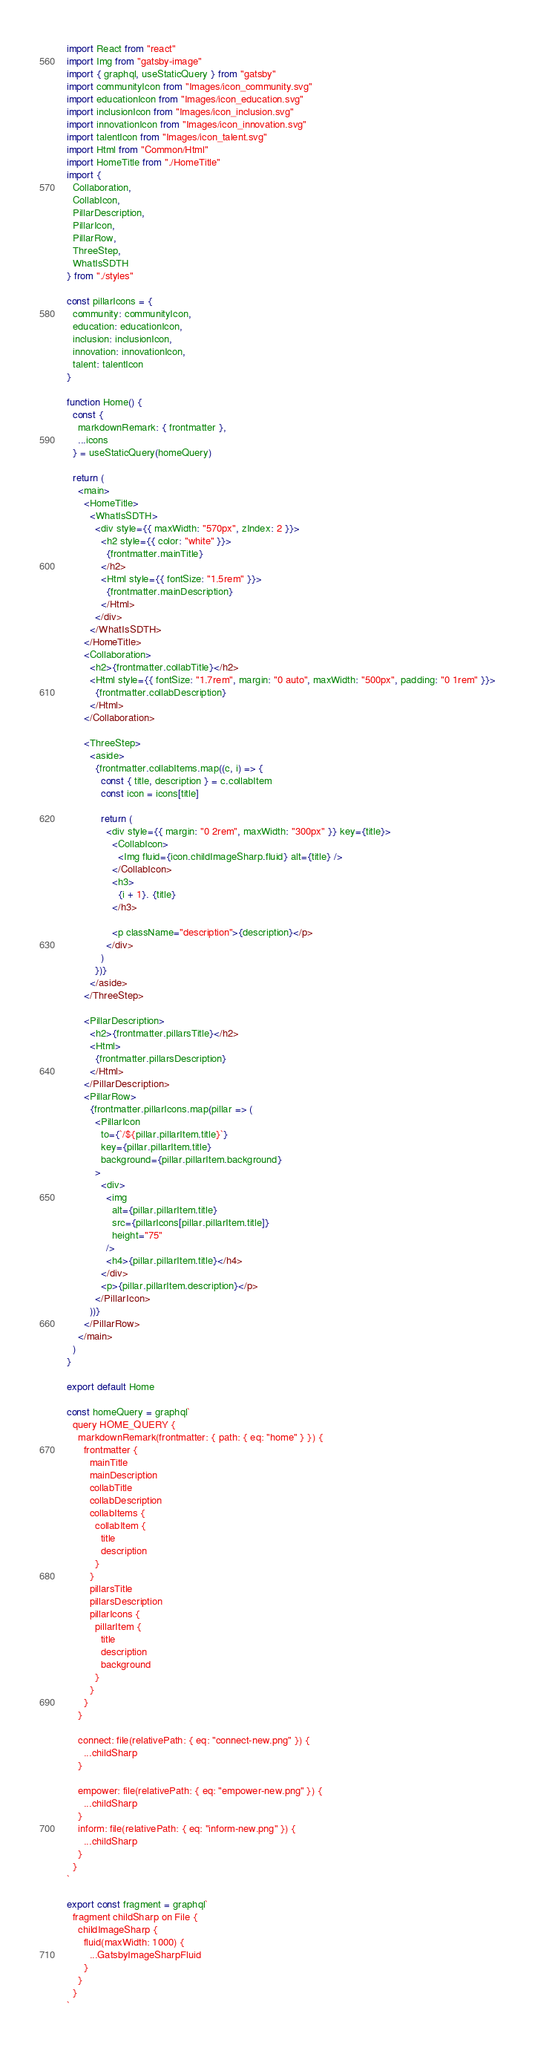<code> <loc_0><loc_0><loc_500><loc_500><_JavaScript_>import React from "react"
import Img from "gatsby-image"
import { graphql, useStaticQuery } from "gatsby"
import communityIcon from "Images/icon_community.svg"
import educationIcon from "Images/icon_education.svg"
import inclusionIcon from "Images/icon_inclusion.svg"
import innovationIcon from "Images/icon_innovation.svg"
import talentIcon from "Images/icon_talent.svg"
import Html from "Common/Html"
import HomeTitle from "./HomeTitle"
import {
  Collaboration,
  CollabIcon,
  PillarDescription,
  PillarIcon,
  PillarRow,
  ThreeStep,
  WhatIsSDTH
} from "./styles"

const pillarIcons = {
  community: communityIcon,
  education: educationIcon,
  inclusion: inclusionIcon,
  innovation: innovationIcon,
  talent: talentIcon
}

function Home() {
  const {
    markdownRemark: { frontmatter },
    ...icons
  } = useStaticQuery(homeQuery)

  return (
    <main>
      <HomeTitle>
        <WhatIsSDTH>
          <div style={{ maxWidth: "570px", zIndex: 2 }}>
            <h2 style={{ color: "white" }}>
              {frontmatter.mainTitle}
            </h2>
            <Html style={{ fontSize: "1.5rem" }}>
              {frontmatter.mainDescription}
            </Html>
          </div>
        </WhatIsSDTH>
      </HomeTitle>
      <Collaboration>
        <h2>{frontmatter.collabTitle}</h2>
        <Html style={{ fontSize: "1.7rem", margin: "0 auto", maxWidth: "500px", padding: "0 1rem" }}>
          {frontmatter.collabDescription}
        </Html>
      </Collaboration>

      <ThreeStep>
        <aside>
          {frontmatter.collabItems.map((c, i) => {
            const { title, description } = c.collabItem
            const icon = icons[title]

            return (
              <div style={{ margin: "0 2rem", maxWidth: "300px" }} key={title}>
                <CollabIcon>
                  <Img fluid={icon.childImageSharp.fluid} alt={title} />
                </CollabIcon>
                <h3>
                  {i + 1}. {title}
                </h3>

                <p className="description">{description}</p>
              </div>
            )
          })}
        </aside>
      </ThreeStep>

      <PillarDescription>
        <h2>{frontmatter.pillarsTitle}</h2>
        <Html>
          {frontmatter.pillarsDescription}
        </Html>
      </PillarDescription>
      <PillarRow>
        {frontmatter.pillarIcons.map(pillar => (
          <PillarIcon
            to={`/${pillar.pillarItem.title}`}
            key={pillar.pillarItem.title}
            background={pillar.pillarItem.background}
          >
            <div>
              <img
                alt={pillar.pillarItem.title}
                src={pillarIcons[pillar.pillarItem.title]}
                height="75"
              />
              <h4>{pillar.pillarItem.title}</h4>
            </div>
            <p>{pillar.pillarItem.description}</p>
          </PillarIcon>
        ))}
      </PillarRow>
    </main>
  )
}

export default Home

const homeQuery = graphql`
  query HOME_QUERY {
    markdownRemark(frontmatter: { path: { eq: "home" } }) {
      frontmatter {
        mainTitle
        mainDescription
        collabTitle
        collabDescription
        collabItems {
          collabItem {
            title
            description
          }
        }
        pillarsTitle
        pillarsDescription
        pillarIcons {
          pillarItem {
            title
            description
            background
          }
        }
      }
    }

    connect: file(relativePath: { eq: "connect-new.png" }) {
      ...childSharp
    }

    empower: file(relativePath: { eq: "empower-new.png" }) {
      ...childSharp
    }
    inform: file(relativePath: { eq: "inform-new.png" }) {
      ...childSharp
    }
  }
`

export const fragment = graphql`
  fragment childSharp on File {
    childImageSharp {
      fluid(maxWidth: 1000) {
        ...GatsbyImageSharpFluid
      }
    }
  }
`
</code> 